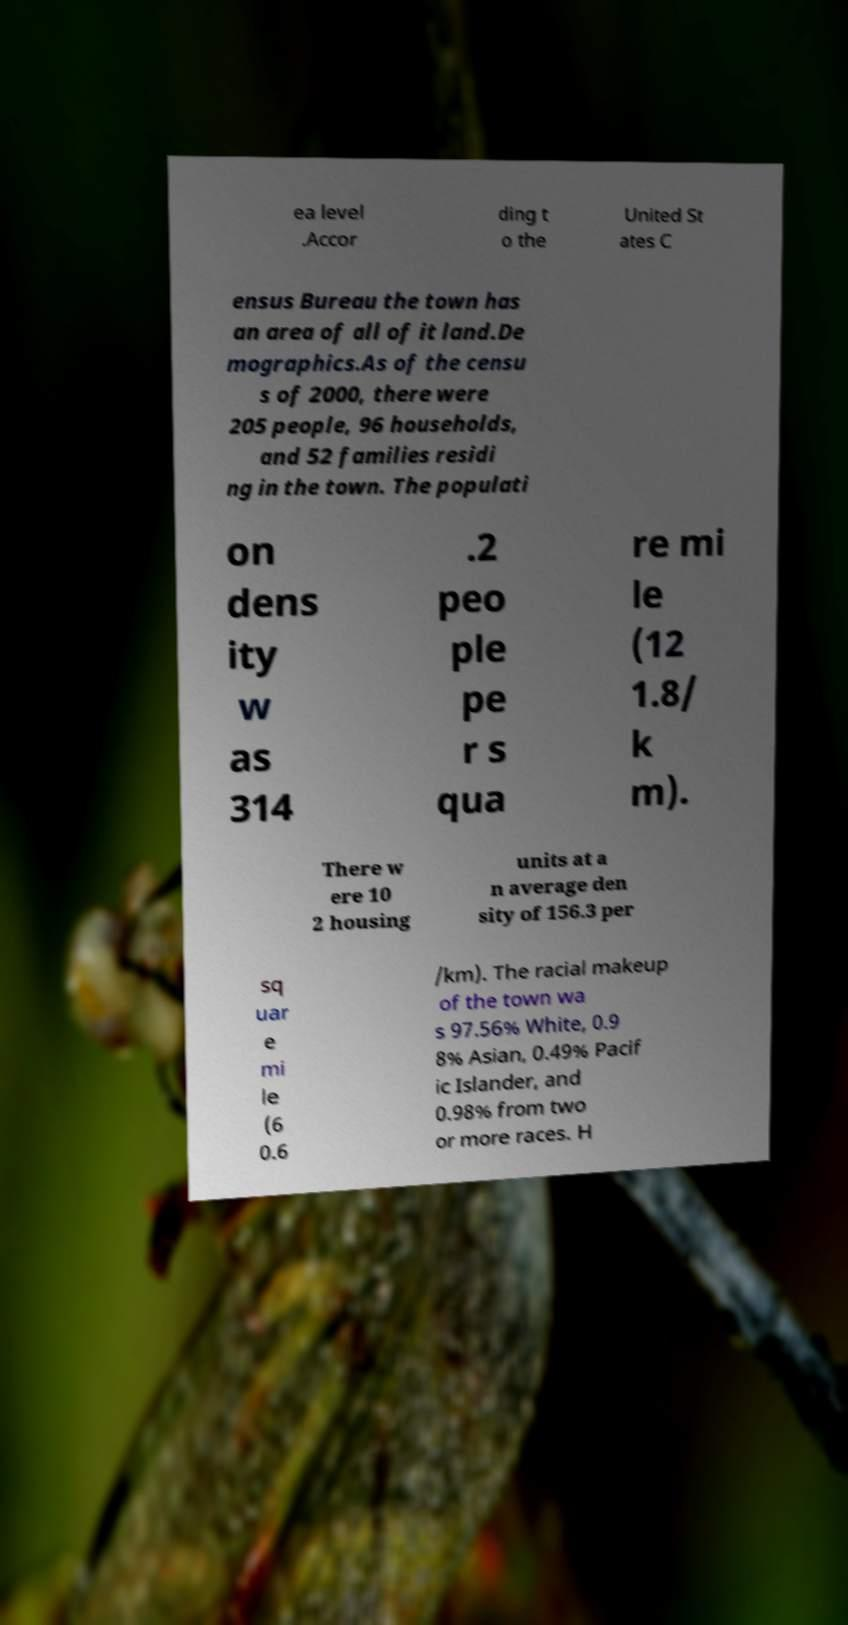Can you read and provide the text displayed in the image?This photo seems to have some interesting text. Can you extract and type it out for me? ea level .Accor ding t o the United St ates C ensus Bureau the town has an area of all of it land.De mographics.As of the censu s of 2000, there were 205 people, 96 households, and 52 families residi ng in the town. The populati on dens ity w as 314 .2 peo ple pe r s qua re mi le (12 1.8/ k m). There w ere 10 2 housing units at a n average den sity of 156.3 per sq uar e mi le (6 0.6 /km). The racial makeup of the town wa s 97.56% White, 0.9 8% Asian, 0.49% Pacif ic Islander, and 0.98% from two or more races. H 